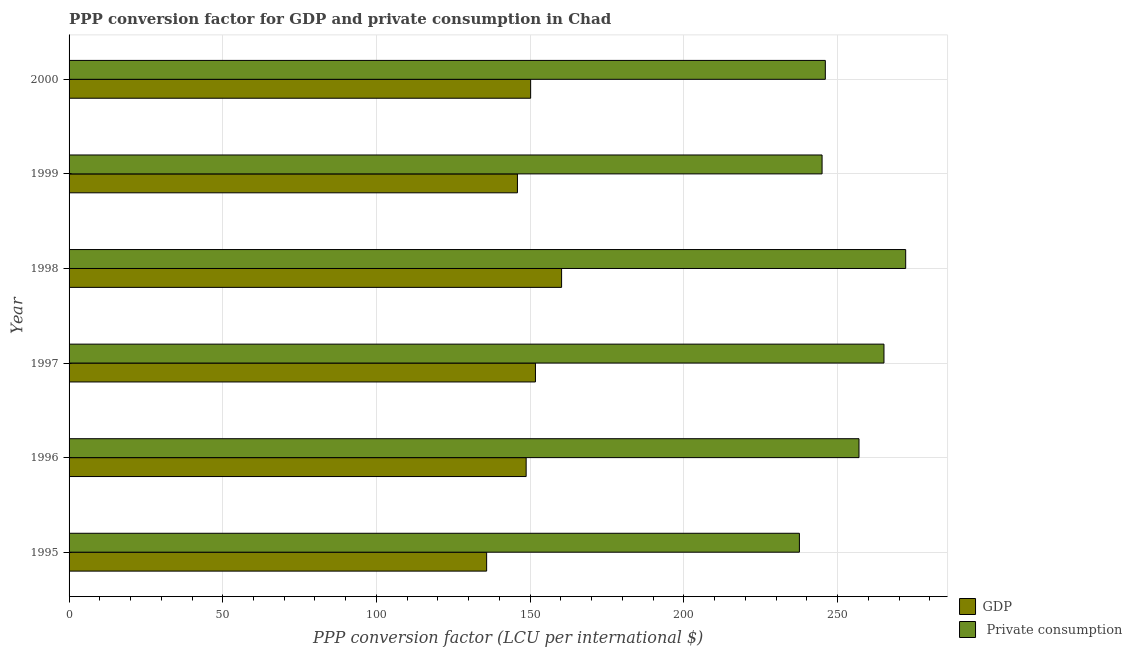How many different coloured bars are there?
Give a very brief answer. 2. How many groups of bars are there?
Your answer should be compact. 6. Are the number of bars per tick equal to the number of legend labels?
Your answer should be very brief. Yes. Are the number of bars on each tick of the Y-axis equal?
Give a very brief answer. Yes. How many bars are there on the 1st tick from the top?
Your answer should be very brief. 2. How many bars are there on the 5th tick from the bottom?
Offer a very short reply. 2. In how many cases, is the number of bars for a given year not equal to the number of legend labels?
Ensure brevity in your answer.  0. What is the ppp conversion factor for private consumption in 2000?
Offer a terse response. 246.01. Across all years, what is the maximum ppp conversion factor for gdp?
Offer a terse response. 160.22. Across all years, what is the minimum ppp conversion factor for gdp?
Your answer should be very brief. 135.84. In which year was the ppp conversion factor for gdp maximum?
Provide a short and direct response. 1998. What is the total ppp conversion factor for private consumption in the graph?
Provide a succinct answer. 1522.78. What is the difference between the ppp conversion factor for private consumption in 1995 and that in 1998?
Your answer should be compact. -34.58. What is the difference between the ppp conversion factor for private consumption in 2000 and the ppp conversion factor for gdp in 1997?
Ensure brevity in your answer.  94.3. What is the average ppp conversion factor for gdp per year?
Your answer should be compact. 148.75. In the year 1996, what is the difference between the ppp conversion factor for private consumption and ppp conversion factor for gdp?
Offer a very short reply. 108.28. In how many years, is the ppp conversion factor for private consumption greater than 50 LCU?
Keep it short and to the point. 6. What is the ratio of the ppp conversion factor for gdp in 1995 to that in 1997?
Your answer should be very brief. 0.9. Is the ppp conversion factor for gdp in 1997 less than that in 2000?
Offer a very short reply. No. What is the difference between the highest and the second highest ppp conversion factor for gdp?
Provide a short and direct response. 8.5. What is the difference between the highest and the lowest ppp conversion factor for gdp?
Offer a very short reply. 24.38. In how many years, is the ppp conversion factor for gdp greater than the average ppp conversion factor for gdp taken over all years?
Ensure brevity in your answer.  3. What does the 1st bar from the top in 1999 represents?
Ensure brevity in your answer.   Private consumption. What does the 1st bar from the bottom in 1997 represents?
Make the answer very short. GDP. Are all the bars in the graph horizontal?
Provide a short and direct response. Yes. What is the difference between two consecutive major ticks on the X-axis?
Provide a short and direct response. 50. Does the graph contain any zero values?
Give a very brief answer. No. Does the graph contain grids?
Your answer should be very brief. Yes. Where does the legend appear in the graph?
Keep it short and to the point. Bottom right. How many legend labels are there?
Ensure brevity in your answer.  2. How are the legend labels stacked?
Offer a terse response. Vertical. What is the title of the graph?
Give a very brief answer. PPP conversion factor for GDP and private consumption in Chad. What is the label or title of the X-axis?
Ensure brevity in your answer.  PPP conversion factor (LCU per international $). What is the label or title of the Y-axis?
Provide a short and direct response. Year. What is the PPP conversion factor (LCU per international $) of GDP in 1995?
Keep it short and to the point. 135.84. What is the PPP conversion factor (LCU per international $) of  Private consumption in 1995?
Provide a succinct answer. 237.58. What is the PPP conversion factor (LCU per international $) in GDP in 1996?
Offer a terse response. 148.69. What is the PPP conversion factor (LCU per international $) of  Private consumption in 1996?
Give a very brief answer. 256.97. What is the PPP conversion factor (LCU per international $) in GDP in 1997?
Offer a very short reply. 151.72. What is the PPP conversion factor (LCU per international $) in  Private consumption in 1997?
Provide a succinct answer. 265.09. What is the PPP conversion factor (LCU per international $) in GDP in 1998?
Your answer should be compact. 160.22. What is the PPP conversion factor (LCU per international $) in  Private consumption in 1998?
Your answer should be very brief. 272.16. What is the PPP conversion factor (LCU per international $) of GDP in 1999?
Provide a short and direct response. 145.85. What is the PPP conversion factor (LCU per international $) of  Private consumption in 1999?
Keep it short and to the point. 244.96. What is the PPP conversion factor (LCU per international $) in GDP in 2000?
Your response must be concise. 150.15. What is the PPP conversion factor (LCU per international $) of  Private consumption in 2000?
Give a very brief answer. 246.01. Across all years, what is the maximum PPP conversion factor (LCU per international $) in GDP?
Offer a terse response. 160.22. Across all years, what is the maximum PPP conversion factor (LCU per international $) in  Private consumption?
Provide a succinct answer. 272.16. Across all years, what is the minimum PPP conversion factor (LCU per international $) of GDP?
Keep it short and to the point. 135.84. Across all years, what is the minimum PPP conversion factor (LCU per international $) in  Private consumption?
Ensure brevity in your answer.  237.58. What is the total PPP conversion factor (LCU per international $) of GDP in the graph?
Provide a succinct answer. 892.48. What is the total PPP conversion factor (LCU per international $) in  Private consumption in the graph?
Offer a terse response. 1522.78. What is the difference between the PPP conversion factor (LCU per international $) of GDP in 1995 and that in 1996?
Give a very brief answer. -12.85. What is the difference between the PPP conversion factor (LCU per international $) in  Private consumption in 1995 and that in 1996?
Offer a very short reply. -19.39. What is the difference between the PPP conversion factor (LCU per international $) of GDP in 1995 and that in 1997?
Your response must be concise. -15.88. What is the difference between the PPP conversion factor (LCU per international $) of  Private consumption in 1995 and that in 1997?
Offer a terse response. -27.51. What is the difference between the PPP conversion factor (LCU per international $) in GDP in 1995 and that in 1998?
Your answer should be compact. -24.38. What is the difference between the PPP conversion factor (LCU per international $) in  Private consumption in 1995 and that in 1998?
Ensure brevity in your answer.  -34.58. What is the difference between the PPP conversion factor (LCU per international $) in GDP in 1995 and that in 1999?
Provide a succinct answer. -10.01. What is the difference between the PPP conversion factor (LCU per international $) in  Private consumption in 1995 and that in 1999?
Ensure brevity in your answer.  -7.37. What is the difference between the PPP conversion factor (LCU per international $) of GDP in 1995 and that in 2000?
Ensure brevity in your answer.  -14.31. What is the difference between the PPP conversion factor (LCU per international $) of  Private consumption in 1995 and that in 2000?
Keep it short and to the point. -8.43. What is the difference between the PPP conversion factor (LCU per international $) of GDP in 1996 and that in 1997?
Provide a succinct answer. -3.03. What is the difference between the PPP conversion factor (LCU per international $) in  Private consumption in 1996 and that in 1997?
Offer a terse response. -8.12. What is the difference between the PPP conversion factor (LCU per international $) in GDP in 1996 and that in 1998?
Offer a terse response. -11.53. What is the difference between the PPP conversion factor (LCU per international $) in  Private consumption in 1996 and that in 1998?
Make the answer very short. -15.19. What is the difference between the PPP conversion factor (LCU per international $) in GDP in 1996 and that in 1999?
Offer a terse response. 2.84. What is the difference between the PPP conversion factor (LCU per international $) of  Private consumption in 1996 and that in 1999?
Ensure brevity in your answer.  12.01. What is the difference between the PPP conversion factor (LCU per international $) of GDP in 1996 and that in 2000?
Provide a short and direct response. -1.46. What is the difference between the PPP conversion factor (LCU per international $) in  Private consumption in 1996 and that in 2000?
Make the answer very short. 10.96. What is the difference between the PPP conversion factor (LCU per international $) in GDP in 1997 and that in 1998?
Your response must be concise. -8.5. What is the difference between the PPP conversion factor (LCU per international $) in  Private consumption in 1997 and that in 1998?
Your answer should be very brief. -7.07. What is the difference between the PPP conversion factor (LCU per international $) in GDP in 1997 and that in 1999?
Give a very brief answer. 5.86. What is the difference between the PPP conversion factor (LCU per international $) in  Private consumption in 1997 and that in 1999?
Give a very brief answer. 20.14. What is the difference between the PPP conversion factor (LCU per international $) in GDP in 1997 and that in 2000?
Keep it short and to the point. 1.57. What is the difference between the PPP conversion factor (LCU per international $) in  Private consumption in 1997 and that in 2000?
Ensure brevity in your answer.  19.08. What is the difference between the PPP conversion factor (LCU per international $) of GDP in 1998 and that in 1999?
Your answer should be compact. 14.37. What is the difference between the PPP conversion factor (LCU per international $) of  Private consumption in 1998 and that in 1999?
Offer a terse response. 27.2. What is the difference between the PPP conversion factor (LCU per international $) of GDP in 1998 and that in 2000?
Offer a very short reply. 10.07. What is the difference between the PPP conversion factor (LCU per international $) in  Private consumption in 1998 and that in 2000?
Keep it short and to the point. 26.14. What is the difference between the PPP conversion factor (LCU per international $) in GDP in 1999 and that in 2000?
Offer a terse response. -4.3. What is the difference between the PPP conversion factor (LCU per international $) of  Private consumption in 1999 and that in 2000?
Keep it short and to the point. -1.06. What is the difference between the PPP conversion factor (LCU per international $) of GDP in 1995 and the PPP conversion factor (LCU per international $) of  Private consumption in 1996?
Your response must be concise. -121.13. What is the difference between the PPP conversion factor (LCU per international $) of GDP in 1995 and the PPP conversion factor (LCU per international $) of  Private consumption in 1997?
Give a very brief answer. -129.25. What is the difference between the PPP conversion factor (LCU per international $) of GDP in 1995 and the PPP conversion factor (LCU per international $) of  Private consumption in 1998?
Provide a succinct answer. -136.32. What is the difference between the PPP conversion factor (LCU per international $) in GDP in 1995 and the PPP conversion factor (LCU per international $) in  Private consumption in 1999?
Provide a succinct answer. -109.12. What is the difference between the PPP conversion factor (LCU per international $) of GDP in 1995 and the PPP conversion factor (LCU per international $) of  Private consumption in 2000?
Provide a succinct answer. -110.17. What is the difference between the PPP conversion factor (LCU per international $) of GDP in 1996 and the PPP conversion factor (LCU per international $) of  Private consumption in 1997?
Your answer should be compact. -116.4. What is the difference between the PPP conversion factor (LCU per international $) of GDP in 1996 and the PPP conversion factor (LCU per international $) of  Private consumption in 1998?
Make the answer very short. -123.47. What is the difference between the PPP conversion factor (LCU per international $) of GDP in 1996 and the PPP conversion factor (LCU per international $) of  Private consumption in 1999?
Provide a succinct answer. -96.27. What is the difference between the PPP conversion factor (LCU per international $) of GDP in 1996 and the PPP conversion factor (LCU per international $) of  Private consumption in 2000?
Make the answer very short. -97.32. What is the difference between the PPP conversion factor (LCU per international $) in GDP in 1997 and the PPP conversion factor (LCU per international $) in  Private consumption in 1998?
Keep it short and to the point. -120.44. What is the difference between the PPP conversion factor (LCU per international $) in GDP in 1997 and the PPP conversion factor (LCU per international $) in  Private consumption in 1999?
Ensure brevity in your answer.  -93.24. What is the difference between the PPP conversion factor (LCU per international $) in GDP in 1997 and the PPP conversion factor (LCU per international $) in  Private consumption in 2000?
Give a very brief answer. -94.3. What is the difference between the PPP conversion factor (LCU per international $) of GDP in 1998 and the PPP conversion factor (LCU per international $) of  Private consumption in 1999?
Your answer should be very brief. -84.74. What is the difference between the PPP conversion factor (LCU per international $) of GDP in 1998 and the PPP conversion factor (LCU per international $) of  Private consumption in 2000?
Offer a very short reply. -85.79. What is the difference between the PPP conversion factor (LCU per international $) of GDP in 1999 and the PPP conversion factor (LCU per international $) of  Private consumption in 2000?
Offer a terse response. -100.16. What is the average PPP conversion factor (LCU per international $) in GDP per year?
Your answer should be very brief. 148.75. What is the average PPP conversion factor (LCU per international $) in  Private consumption per year?
Give a very brief answer. 253.8. In the year 1995, what is the difference between the PPP conversion factor (LCU per international $) in GDP and PPP conversion factor (LCU per international $) in  Private consumption?
Provide a succinct answer. -101.74. In the year 1996, what is the difference between the PPP conversion factor (LCU per international $) of GDP and PPP conversion factor (LCU per international $) of  Private consumption?
Offer a terse response. -108.28. In the year 1997, what is the difference between the PPP conversion factor (LCU per international $) of GDP and PPP conversion factor (LCU per international $) of  Private consumption?
Your answer should be compact. -113.38. In the year 1998, what is the difference between the PPP conversion factor (LCU per international $) of GDP and PPP conversion factor (LCU per international $) of  Private consumption?
Give a very brief answer. -111.94. In the year 1999, what is the difference between the PPP conversion factor (LCU per international $) of GDP and PPP conversion factor (LCU per international $) of  Private consumption?
Keep it short and to the point. -99.1. In the year 2000, what is the difference between the PPP conversion factor (LCU per international $) in GDP and PPP conversion factor (LCU per international $) in  Private consumption?
Your response must be concise. -95.86. What is the ratio of the PPP conversion factor (LCU per international $) in GDP in 1995 to that in 1996?
Provide a short and direct response. 0.91. What is the ratio of the PPP conversion factor (LCU per international $) in  Private consumption in 1995 to that in 1996?
Keep it short and to the point. 0.92. What is the ratio of the PPP conversion factor (LCU per international $) in GDP in 1995 to that in 1997?
Your response must be concise. 0.9. What is the ratio of the PPP conversion factor (LCU per international $) in  Private consumption in 1995 to that in 1997?
Provide a succinct answer. 0.9. What is the ratio of the PPP conversion factor (LCU per international $) in GDP in 1995 to that in 1998?
Keep it short and to the point. 0.85. What is the ratio of the PPP conversion factor (LCU per international $) in  Private consumption in 1995 to that in 1998?
Ensure brevity in your answer.  0.87. What is the ratio of the PPP conversion factor (LCU per international $) of GDP in 1995 to that in 1999?
Your answer should be very brief. 0.93. What is the ratio of the PPP conversion factor (LCU per international $) of  Private consumption in 1995 to that in 1999?
Ensure brevity in your answer.  0.97. What is the ratio of the PPP conversion factor (LCU per international $) of GDP in 1995 to that in 2000?
Ensure brevity in your answer.  0.9. What is the ratio of the PPP conversion factor (LCU per international $) of  Private consumption in 1995 to that in 2000?
Offer a very short reply. 0.97. What is the ratio of the PPP conversion factor (LCU per international $) of GDP in 1996 to that in 1997?
Offer a very short reply. 0.98. What is the ratio of the PPP conversion factor (LCU per international $) of  Private consumption in 1996 to that in 1997?
Ensure brevity in your answer.  0.97. What is the ratio of the PPP conversion factor (LCU per international $) of GDP in 1996 to that in 1998?
Your answer should be very brief. 0.93. What is the ratio of the PPP conversion factor (LCU per international $) of  Private consumption in 1996 to that in 1998?
Keep it short and to the point. 0.94. What is the ratio of the PPP conversion factor (LCU per international $) of GDP in 1996 to that in 1999?
Your response must be concise. 1.02. What is the ratio of the PPP conversion factor (LCU per international $) in  Private consumption in 1996 to that in 1999?
Provide a succinct answer. 1.05. What is the ratio of the PPP conversion factor (LCU per international $) of GDP in 1996 to that in 2000?
Your response must be concise. 0.99. What is the ratio of the PPP conversion factor (LCU per international $) of  Private consumption in 1996 to that in 2000?
Your answer should be very brief. 1.04. What is the ratio of the PPP conversion factor (LCU per international $) in GDP in 1997 to that in 1998?
Provide a succinct answer. 0.95. What is the ratio of the PPP conversion factor (LCU per international $) of GDP in 1997 to that in 1999?
Ensure brevity in your answer.  1.04. What is the ratio of the PPP conversion factor (LCU per international $) in  Private consumption in 1997 to that in 1999?
Offer a terse response. 1.08. What is the ratio of the PPP conversion factor (LCU per international $) in GDP in 1997 to that in 2000?
Your answer should be very brief. 1.01. What is the ratio of the PPP conversion factor (LCU per international $) in  Private consumption in 1997 to that in 2000?
Ensure brevity in your answer.  1.08. What is the ratio of the PPP conversion factor (LCU per international $) of GDP in 1998 to that in 1999?
Offer a terse response. 1.1. What is the ratio of the PPP conversion factor (LCU per international $) of  Private consumption in 1998 to that in 1999?
Offer a terse response. 1.11. What is the ratio of the PPP conversion factor (LCU per international $) of GDP in 1998 to that in 2000?
Your answer should be very brief. 1.07. What is the ratio of the PPP conversion factor (LCU per international $) of  Private consumption in 1998 to that in 2000?
Your answer should be very brief. 1.11. What is the ratio of the PPP conversion factor (LCU per international $) of GDP in 1999 to that in 2000?
Ensure brevity in your answer.  0.97. What is the difference between the highest and the second highest PPP conversion factor (LCU per international $) of GDP?
Ensure brevity in your answer.  8.5. What is the difference between the highest and the second highest PPP conversion factor (LCU per international $) of  Private consumption?
Make the answer very short. 7.07. What is the difference between the highest and the lowest PPP conversion factor (LCU per international $) in GDP?
Offer a terse response. 24.38. What is the difference between the highest and the lowest PPP conversion factor (LCU per international $) in  Private consumption?
Keep it short and to the point. 34.58. 